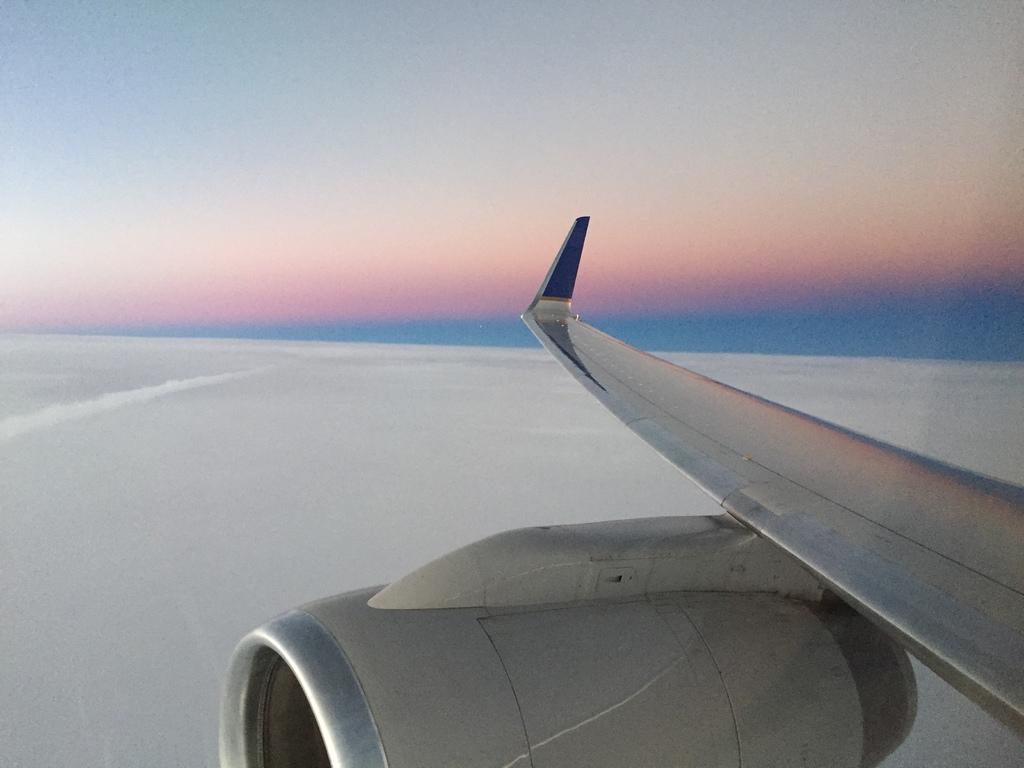How would you summarize this image in a sentence or two? In this image we can see an aeroplane flying in the sky. 